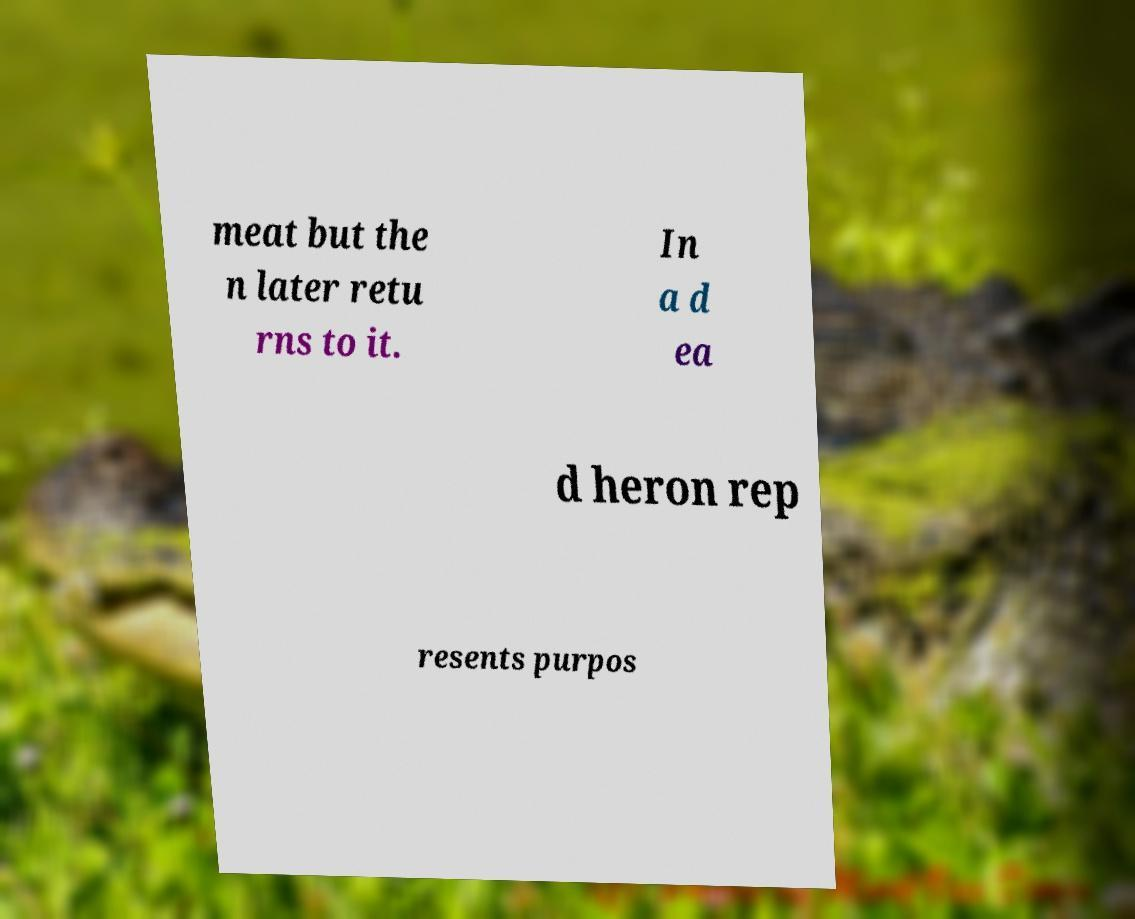There's text embedded in this image that I need extracted. Can you transcribe it verbatim? meat but the n later retu rns to it. In a d ea d heron rep resents purpos 